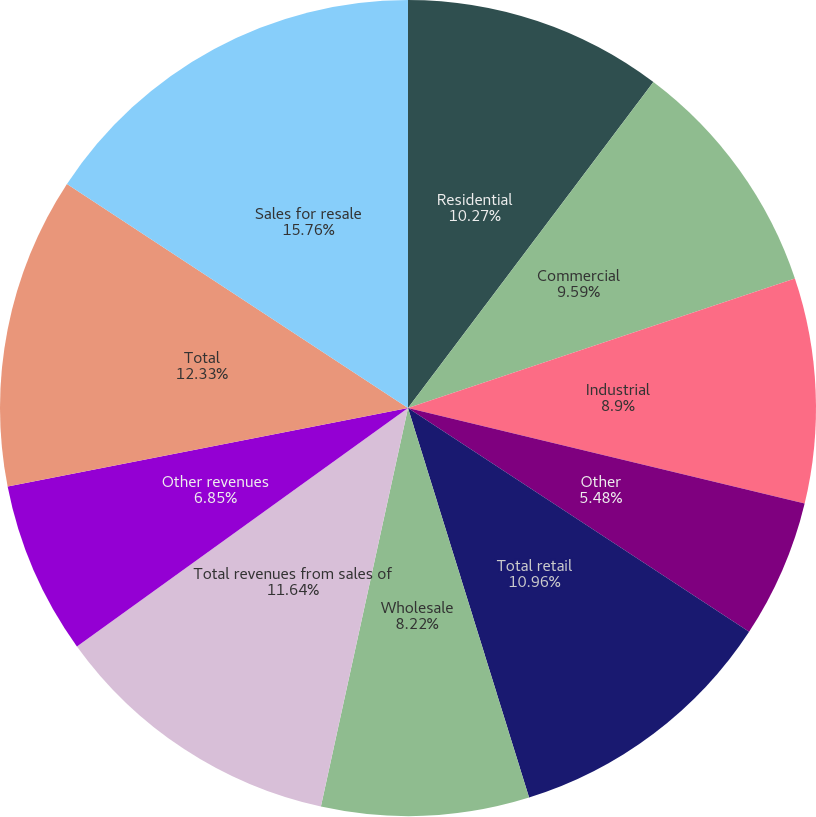Convert chart. <chart><loc_0><loc_0><loc_500><loc_500><pie_chart><fcel>Residential<fcel>Commercial<fcel>Industrial<fcel>Other<fcel>Total retail<fcel>Wholesale<fcel>Total revenues from sales of<fcel>Other revenues<fcel>Total<fcel>Sales for resale<nl><fcel>10.27%<fcel>9.59%<fcel>8.9%<fcel>5.48%<fcel>10.96%<fcel>8.22%<fcel>11.64%<fcel>6.85%<fcel>12.33%<fcel>15.75%<nl></chart> 